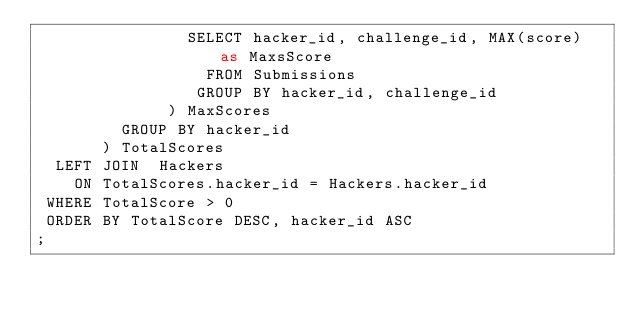Convert code to text. <code><loc_0><loc_0><loc_500><loc_500><_SQL_>                SELECT hacker_id, challenge_id, MAX(score) as MaxsScore
                  FROM Submissions
                 GROUP BY hacker_id, challenge_id
              ) MaxScores
         GROUP BY hacker_id
       ) TotalScores
  LEFT JOIN  Hackers
    ON TotalScores.hacker_id = Hackers.hacker_id
 WHERE TotalScore > 0
 ORDER BY TotalScore DESC, hacker_id ASC
;
</code> 